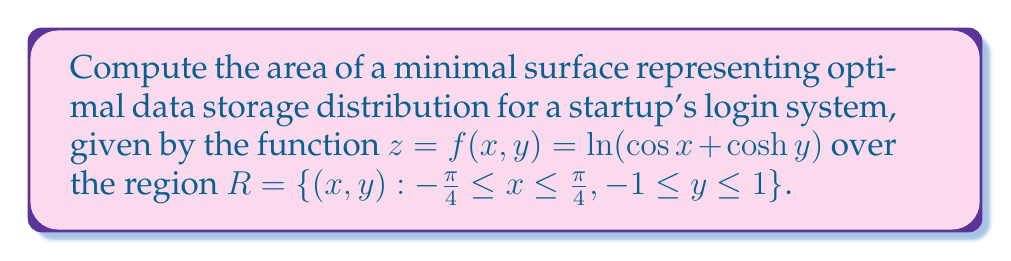Show me your answer to this math problem. To compute the area of the minimal surface, we need to use the surface area formula for a parametric surface:

$$A = \iint_R \sqrt{1 + f_x^2 + f_y^2} \, dxdy$$

1. Calculate partial derivatives:
   $$f_x = -\frac{\sin x}{\cos x + \cosh y}$$
   $$f_y = \frac{\sinh y}{\cos x + \cosh y}$$

2. Substitute into the integrand:
   $$\sqrt{1 + f_x^2 + f_y^2} = \sqrt{1 + \frac{\sin^2 x + \sinh^2 y}{(\cos x + \cosh y)^2}}$$

3. Simplify using trigonometric identities:
   $$\sqrt{1 + f_x^2 + f_y^2} = \frac{\sqrt{(\cos x + \cosh y)^2 + \sin^2 x + \sinh^2 y}}{\cos x + \cosh y}$$
   $$= \frac{\sqrt{\cos^2 x + 2\cos x \cosh y + \cosh^2 y + \sin^2 x + \sinh^2 y}}{\cos x + \cosh y}$$
   $$= \frac{\sqrt{1 + 2\cos x \cosh y + (\cosh^2 y + \sinh^2 y)}}{\cos x + \cosh y}$$
   $$= \frac{\sqrt{1 + 2\cos x \cosh y + \cosh 2y}}{\cos x + \cosh y}$$

4. Set up the double integral:
   $$A = \int_{-1}^1 \int_{-\pi/4}^{\pi/4} \frac{\sqrt{1 + 2\cos x \cosh y + \cosh 2y}}{\cos x + \cosh y} \, dxdy$$

5. This integral cannot be evaluated analytically. We need to use numerical integration methods to approximate the result.

6. Using a numerical integration tool (e.g., adaptive quadrature), we can approximate the integral to get:
   $$A \approx 3.62$$
Answer: $3.62$ (square units) 